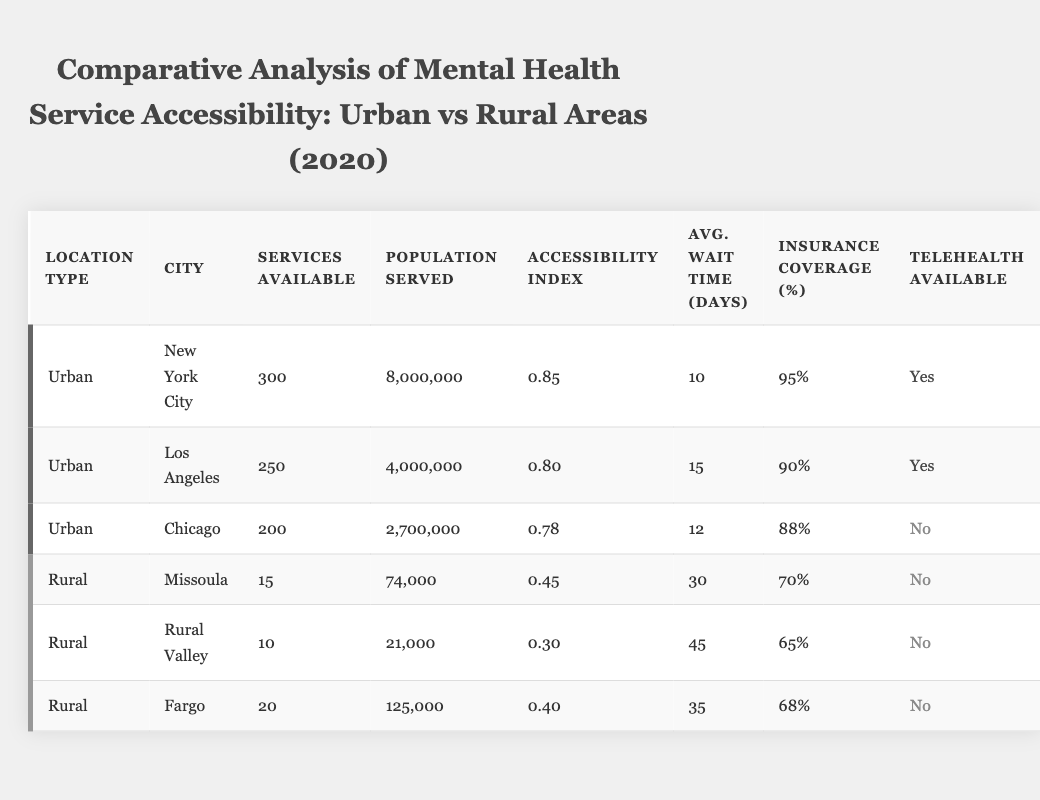What is the accessibility index for New York City? The accessibility index for New York City can be found in the table under the "Accessibility Index" column next to the city name. It shows a value of 0.85.
Answer: 0.85 How many services are available in Chicago? In the table, the number of services available in Chicago is listed under the "Services Available" column, which shows a value of 200.
Answer: 200 What is the average wait time for mental health services in rural areas? To find the average wait time for rural areas, add the wait times for all rural cities (30 + 45 + 35) = 110 days and then divide by the number of rural entries (3). The average wait time is 110 / 3 = 36.67 days.
Answer: 36.67 Does Los Angeles have telehealth services available? In the table, Los Angeles is listed under "Telehealth Available," and it states "Yes," indicating that telehealth services are available in Los Angeles.
Answer: Yes Which city has the highest insurance coverage percentage and what is that percentage? By reviewing the "Insurance Coverage (%)" column, New York City has the highest percentage at 95%.
Answer: 95% What is the difference in services available between New York City and Missoula? The number of services available in New York City is 300, while in Missoula it is 15. The difference is 300 - 15 = 285.
Answer: 285 Is the population served in Rural Valley greater than the population served in Fargo? From the table, the population served in Rural Valley is 21,000 and in Fargo, it is 125,000. Since 21,000 is less than 125,000, the answer is No.
Answer: No How many more patients does New York City serve compared to Missoula? The population served in New York City is 8,000,000 and in Missoula, it is 74,000. The difference is 8,000,000 - 74,000 = 7,926,000.
Answer: 7,926,000 What percentage of the population in Chicago has insurance coverage? From the data in the table, Chicago has insurance coverage listed as 88%.
Answer: 88% Which urban city has the longest average wait time for mental health services? By comparing the "Avg. Wait Time (Days)" for urban cities, Los Angeles has the longest average wait time of 15 days.
Answer: Los Angeles 